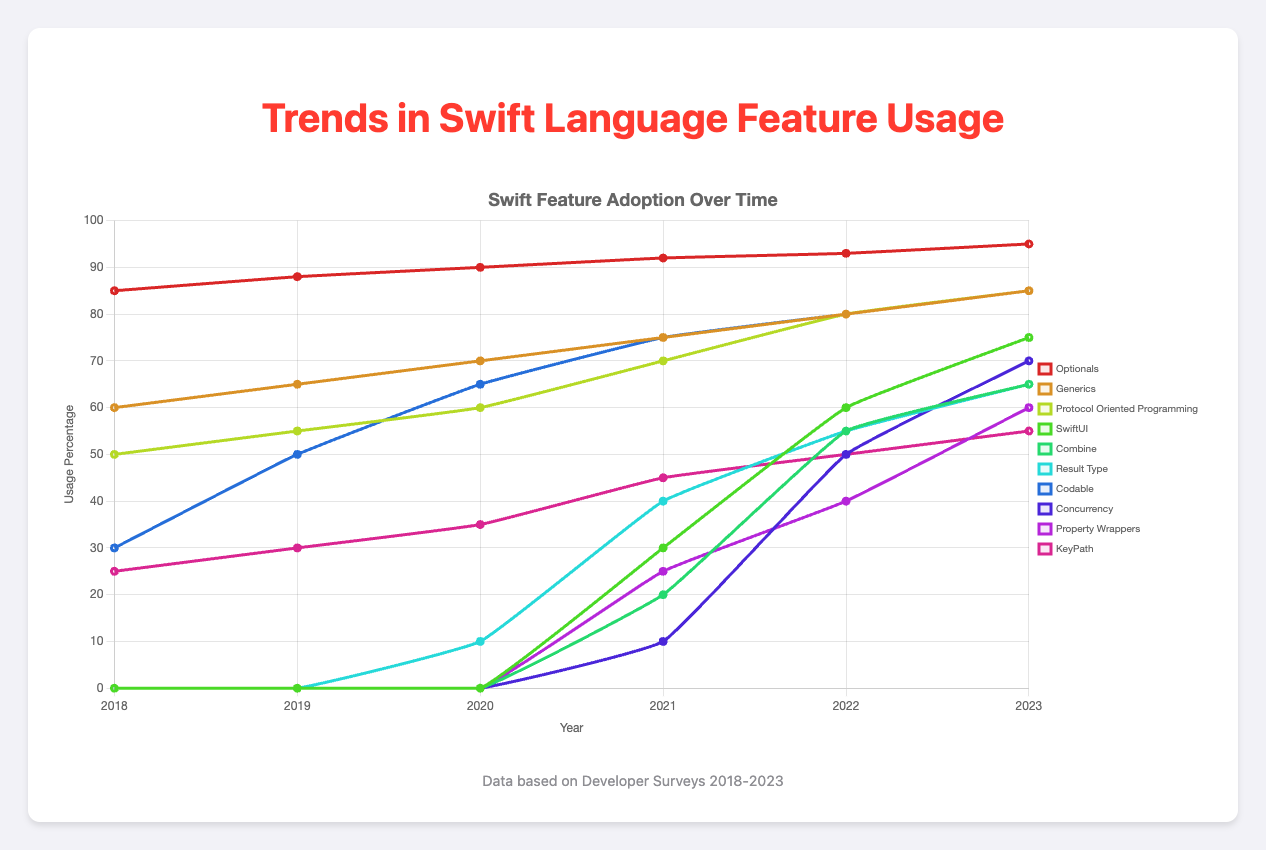What's the trend in usage of SwiftUI from 2018 to 2023? SwiftUI shows an upward trend starting from 0% in 2018 to reaching 75% in 2023.
Answer: Increasing from 0% to 75% Which feature had the highest initial usage in 2018? In 2018, "Optionals" had the highest usage at 85%.
Answer: Optionals at 85% How does the usage of Combine in 2023 compare to its usage in 2020? Combine usage increased from 0% in 2020 to 65% in 2023.
Answer: It increased by 65% What is the difference in the usage of Protocol Oriented Programming from 2018 to 2023? In 2018, the usage was 50%, and it increased to 85% in 2023, resulting in a difference of 35%.
Answer: 35% Which feature shows a constant upward trend every year from 2018 to 2023? "Generics" shows a consistent increase from 60% in 2018 to 85% in 2023, with no drops or plateaus.
Answer: Generics Between 2020 and 2023, which new feature had the highest increase in usage? "SwiftUI" increased from 0% in 2020 to 75% in 2023, showing the highest increase of 75%.
Answer: SwiftUI with 75% Compare the usage of Generics and Codable in 2020. Which had higher usage and by how much? In 2020, Generics had 70% usage, while Codable had 65%. Generics had higher usage by 5%.
Answer: Generics by 5% Which feature saw the most significant jump in usage between any two consecutive years? "SwiftUI" had the most significant jump between 2020 (0%) and 2021 (30%), showing a 30% increase.
Answer: SwiftUI (30%) What is the average usage of KeyPath from 2018 to 2023? The usage data for KeyPath is [25, 30, 35, 45, 50, 55]. Summing these and dividing by 6 gives (25 + 30 + 35 + 45 + 50 + 55) / 6 = 240 / 6 = 40%.
Answer: 40% Which feature reached a 50% usage first among the features listed, and in which year? According to the data, "Optionals" reached 50% usage first, which was already higher than 50% in 2018, the earliest year in the dataset.
Answer: Optionals in 2018 